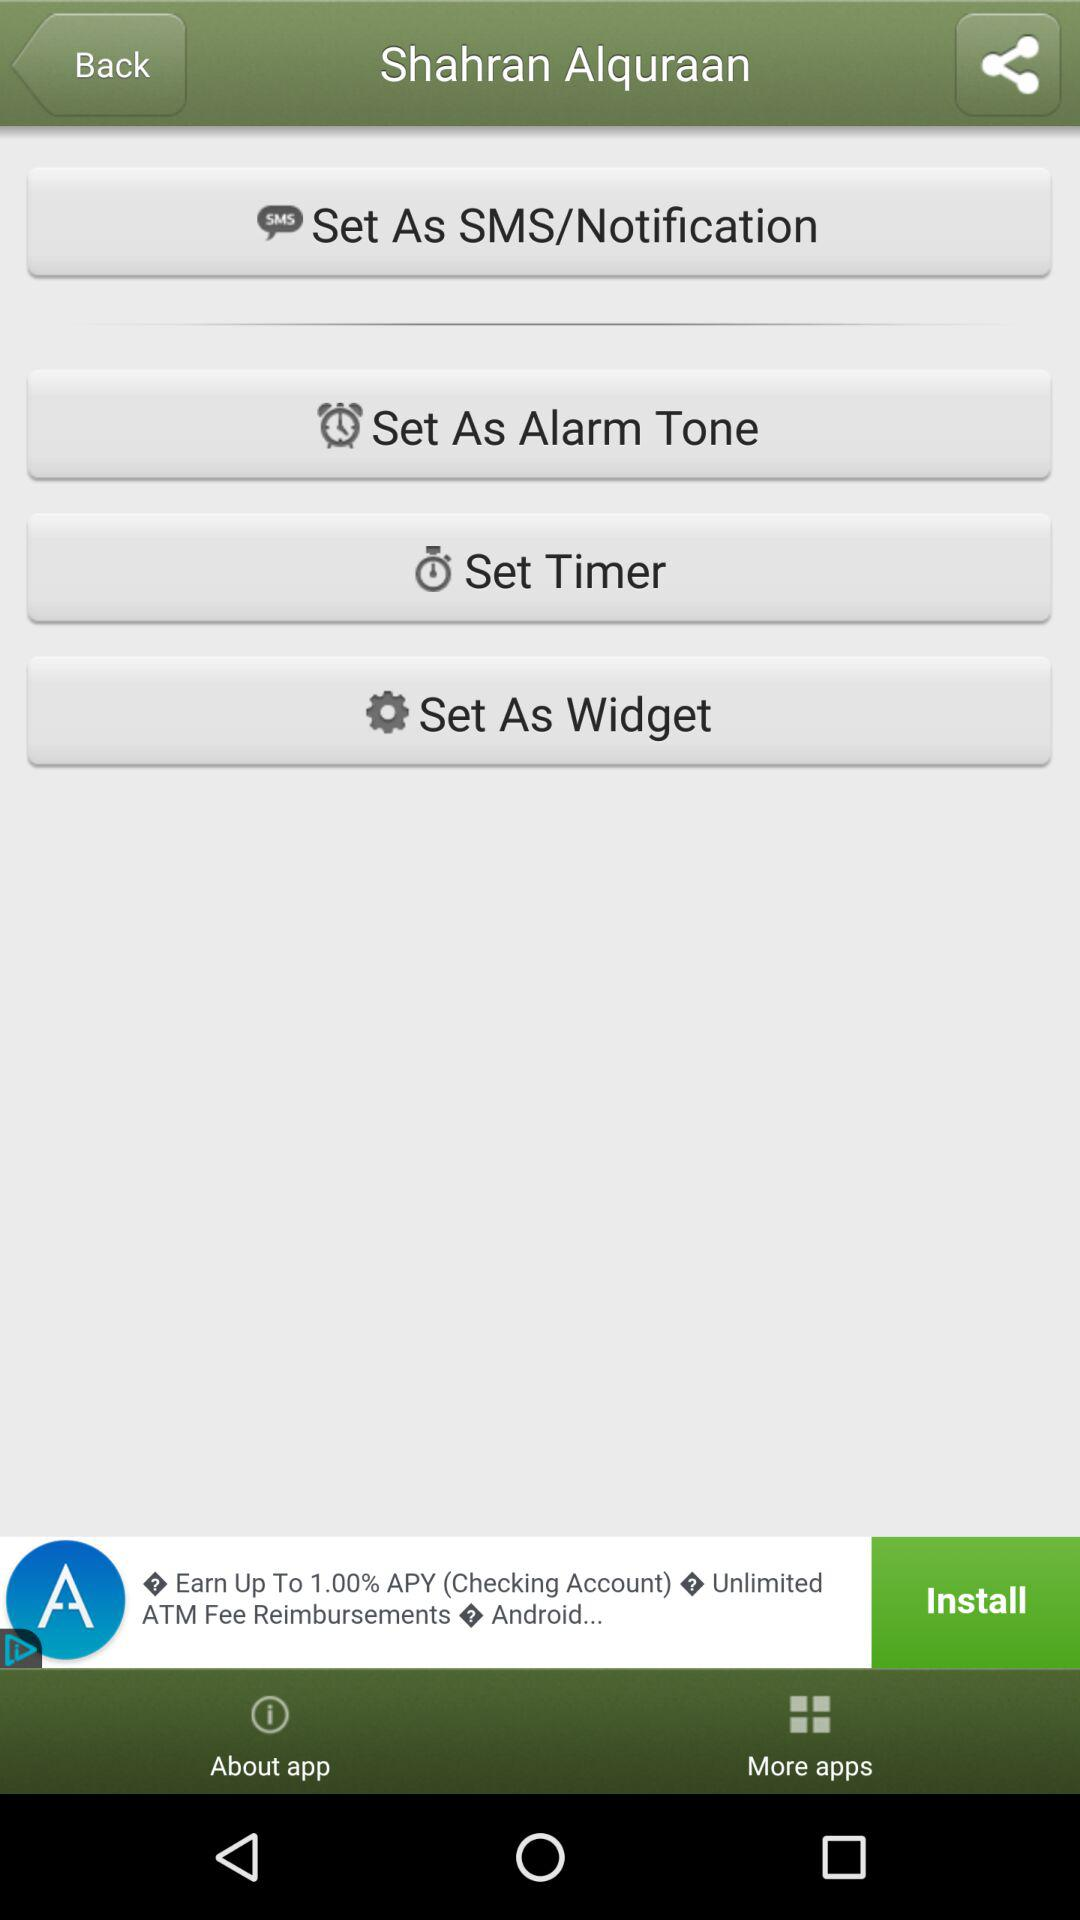What is the application name? The application name is "Shahran Alquraan". 